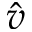<formula> <loc_0><loc_0><loc_500><loc_500>\hat { v }</formula> 